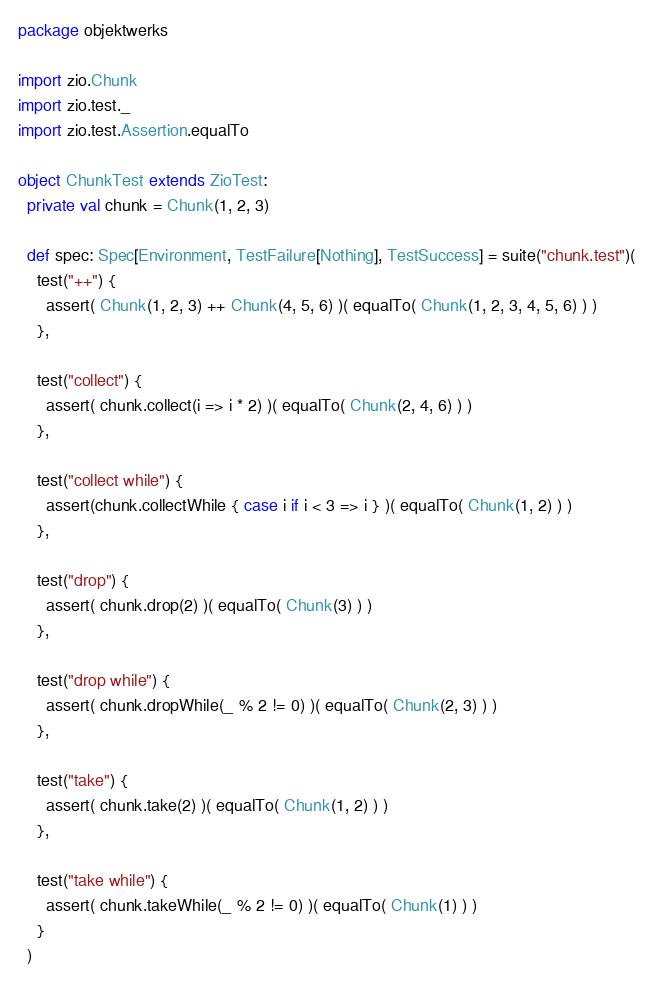<code> <loc_0><loc_0><loc_500><loc_500><_Scala_>package objektwerks

import zio.Chunk
import zio.test._
import zio.test.Assertion.equalTo

object ChunkTest extends ZioTest:
  private val chunk = Chunk(1, 2, 3)

  def spec: Spec[Environment, TestFailure[Nothing], TestSuccess] = suite("chunk.test")(
    test("++") {
      assert( Chunk(1, 2, 3) ++ Chunk(4, 5, 6) )( equalTo( Chunk(1, 2, 3, 4, 5, 6) ) )
    },

    test("collect") {
      assert( chunk.collect(i => i * 2) )( equalTo( Chunk(2, 4, 6) ) )
    },

    test("collect while") {
      assert(chunk.collectWhile { case i if i < 3 => i } )( equalTo( Chunk(1, 2) ) )
    },

    test("drop") {
      assert( chunk.drop(2) )( equalTo( Chunk(3) ) )
    },

    test("drop while") {
      assert( chunk.dropWhile(_ % 2 != 0) )( equalTo( Chunk(2, 3) ) )
    },

    test("take") {
      assert( chunk.take(2) )( equalTo( Chunk(1, 2) ) )
    },

    test("take while") {
      assert( chunk.takeWhile(_ % 2 != 0) )( equalTo( Chunk(1) ) )
    }
  )
</code> 